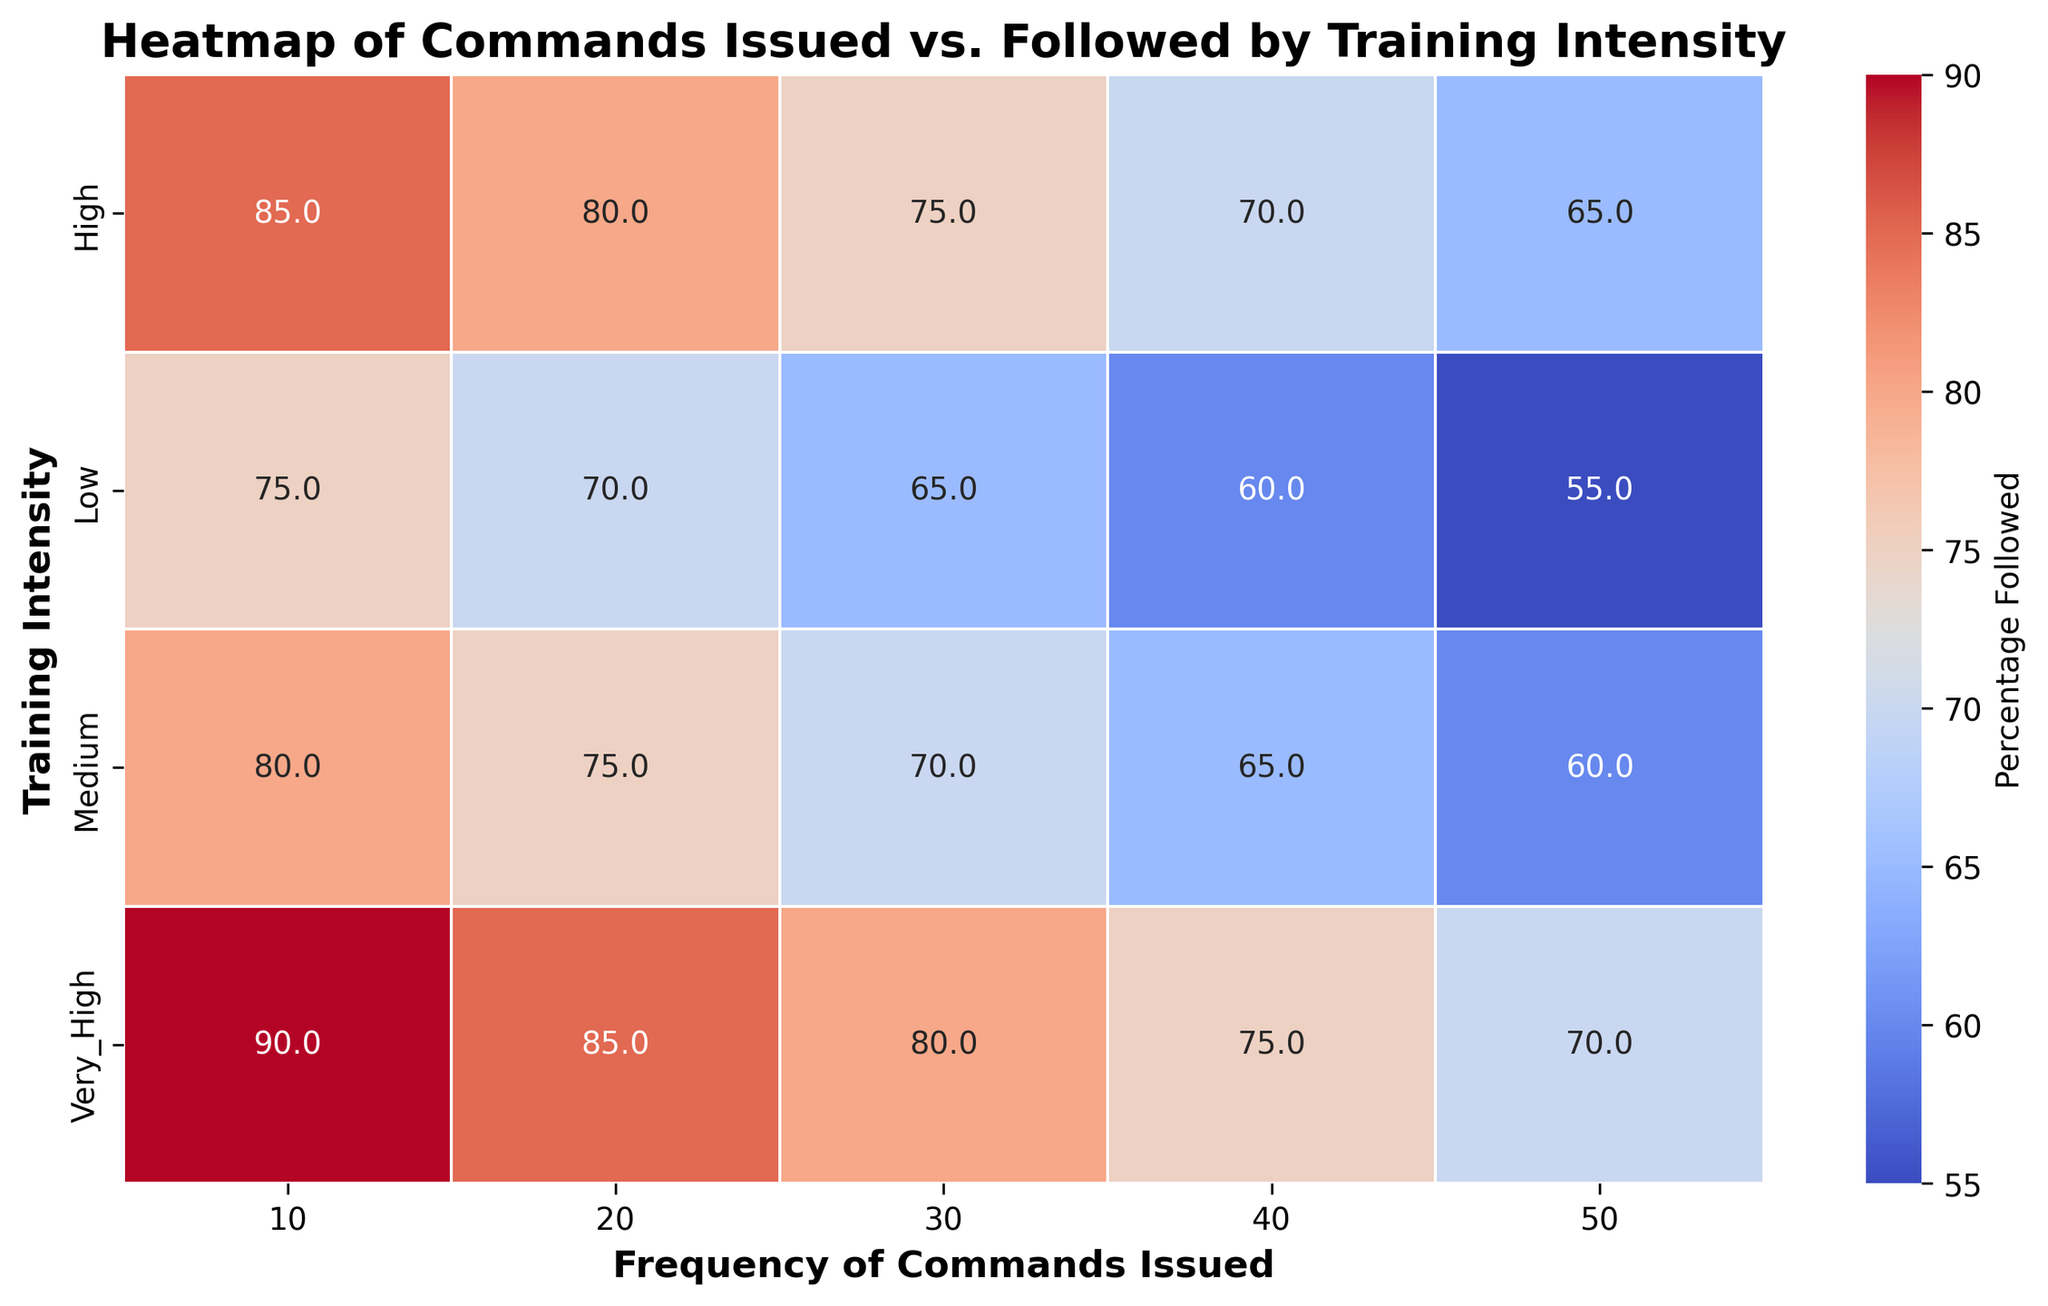What is the value where High training intensity and 30 commands issued intersect? Look at the cell where the High training intensity row and the 30 commands issued column intersect. The value indicated is 75.
Answer: 75 Which training intensity level has the highest percentage followed for 20 commands issued? Identify the values in the column for 20 commands issued across different training intensities. The highest value is 85 under Very High training intensity.
Answer: Very High Compare the percentage followed for 10 commands issued between Low and Very High training intensity. Look at the 10 commands issued column and compare the values for Low (75) and Very High (90) training intensities. The percentage followed is higher for Very High training intensity.
Answer: Higher for Very High training intensity Is the percentage followed increasing or decreasing as the frequency of commands issued increases for Medium training intensity? Observe the values in the Medium training intensity row. Notice that the percentages are 80, 75, 70, 65, and 60 as the frequency of commands increases. The percentage followed is decreasing.
Answer: Decreasing What's the difference in percentage followed for 50 commands issued between Low and High training intensities? Find the values for 50 commands issued under Low (55) and High (65) training intensities. Calculate the difference: 65 - 55 = 10.
Answer: 10 Which color hue is predominantly seen for Medium training intensity for 40 commands issued? Look at the cell for Medium training intensity and 40 commands issued. Notice the color hue, which corresponds to a bluish shade.
Answer: Bluish shade What is the average percentage followed for Very High training intensity across all frequencies of commands issued? List the percentages for Very High training intensity (90, 85, 80, 75, 70). Sum them up: 90 + 85 + 80 + 75 + 70 = 400. Divide by the number of values (5): 400 / 5 = 80.
Answer: 80 Compare the percentage followed between the highest and lowest frequencies of commands issued for Low training intensity. For Low training intensity, the values are 75 (10 commands) and 55 (50 commands). The percentage followed for 10 commands is higher.
Answer: Higher for 10 commands Determine the median percentage followed for Medium training intensity. List the percentages for Medium training intensity (80, 75, 70, 65, 60). The median is the middle value of the ordered list, which is 70.
Answer: 70 